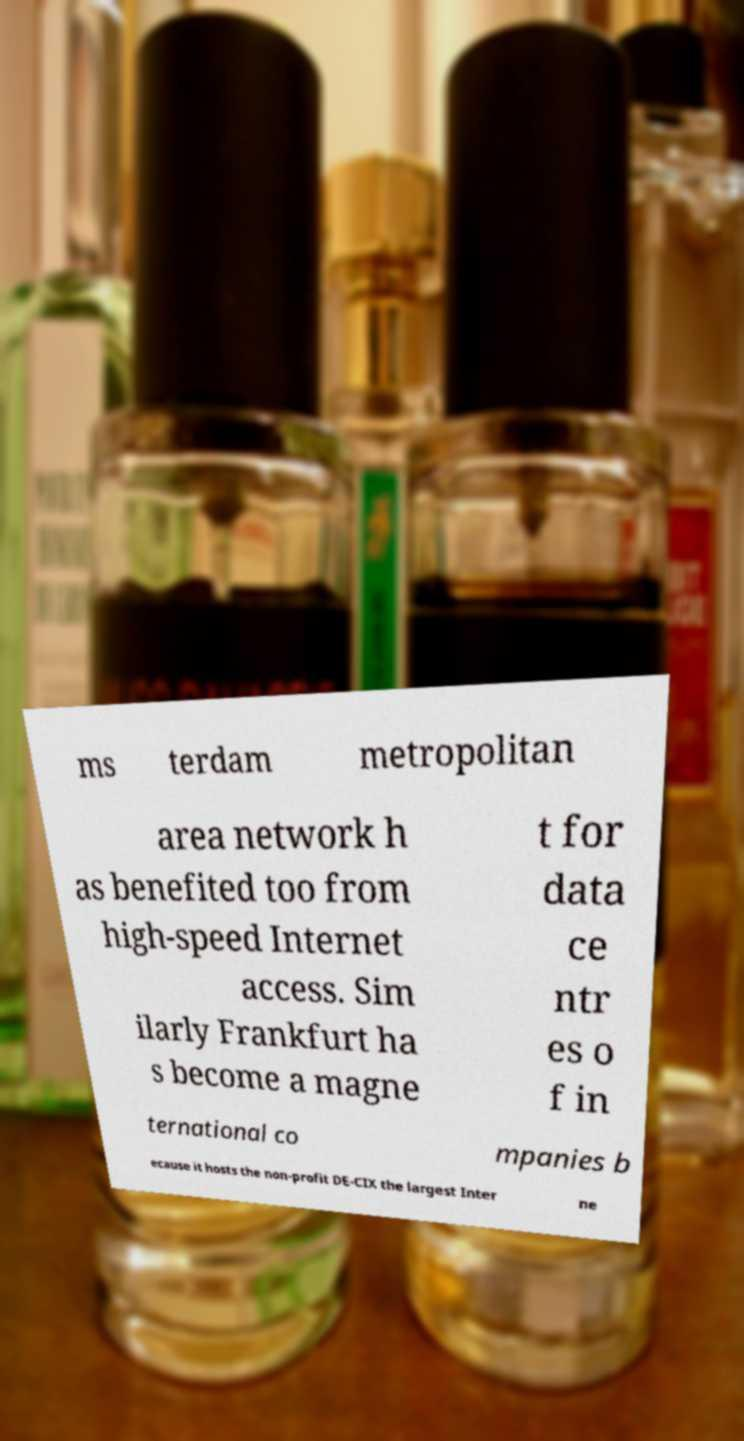Please identify and transcribe the text found in this image. ms terdam metropolitan area network h as benefited too from high-speed Internet access. Sim ilarly Frankfurt ha s become a magne t for data ce ntr es o f in ternational co mpanies b ecause it hosts the non-profit DE-CIX the largest Inter ne 